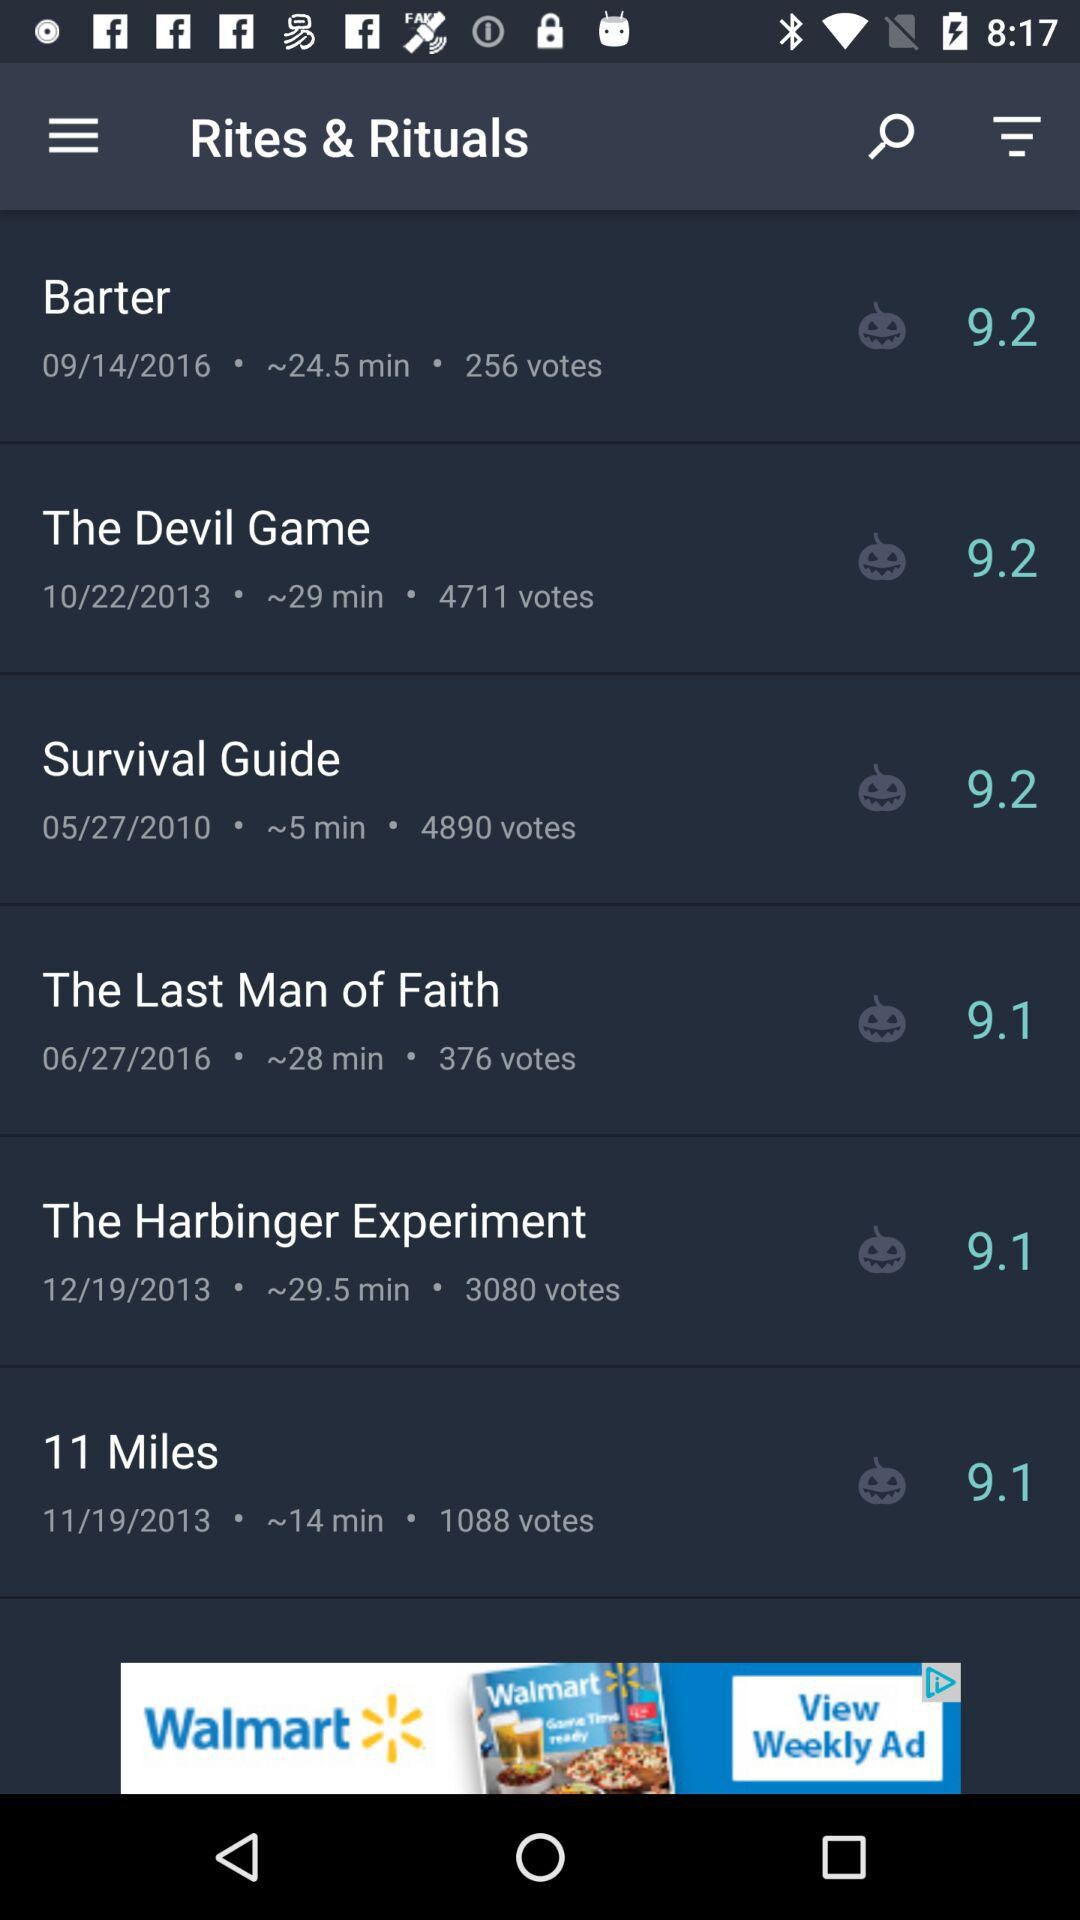How many votes are there for the survival guide? There are 4890 votes for the survival guide. 